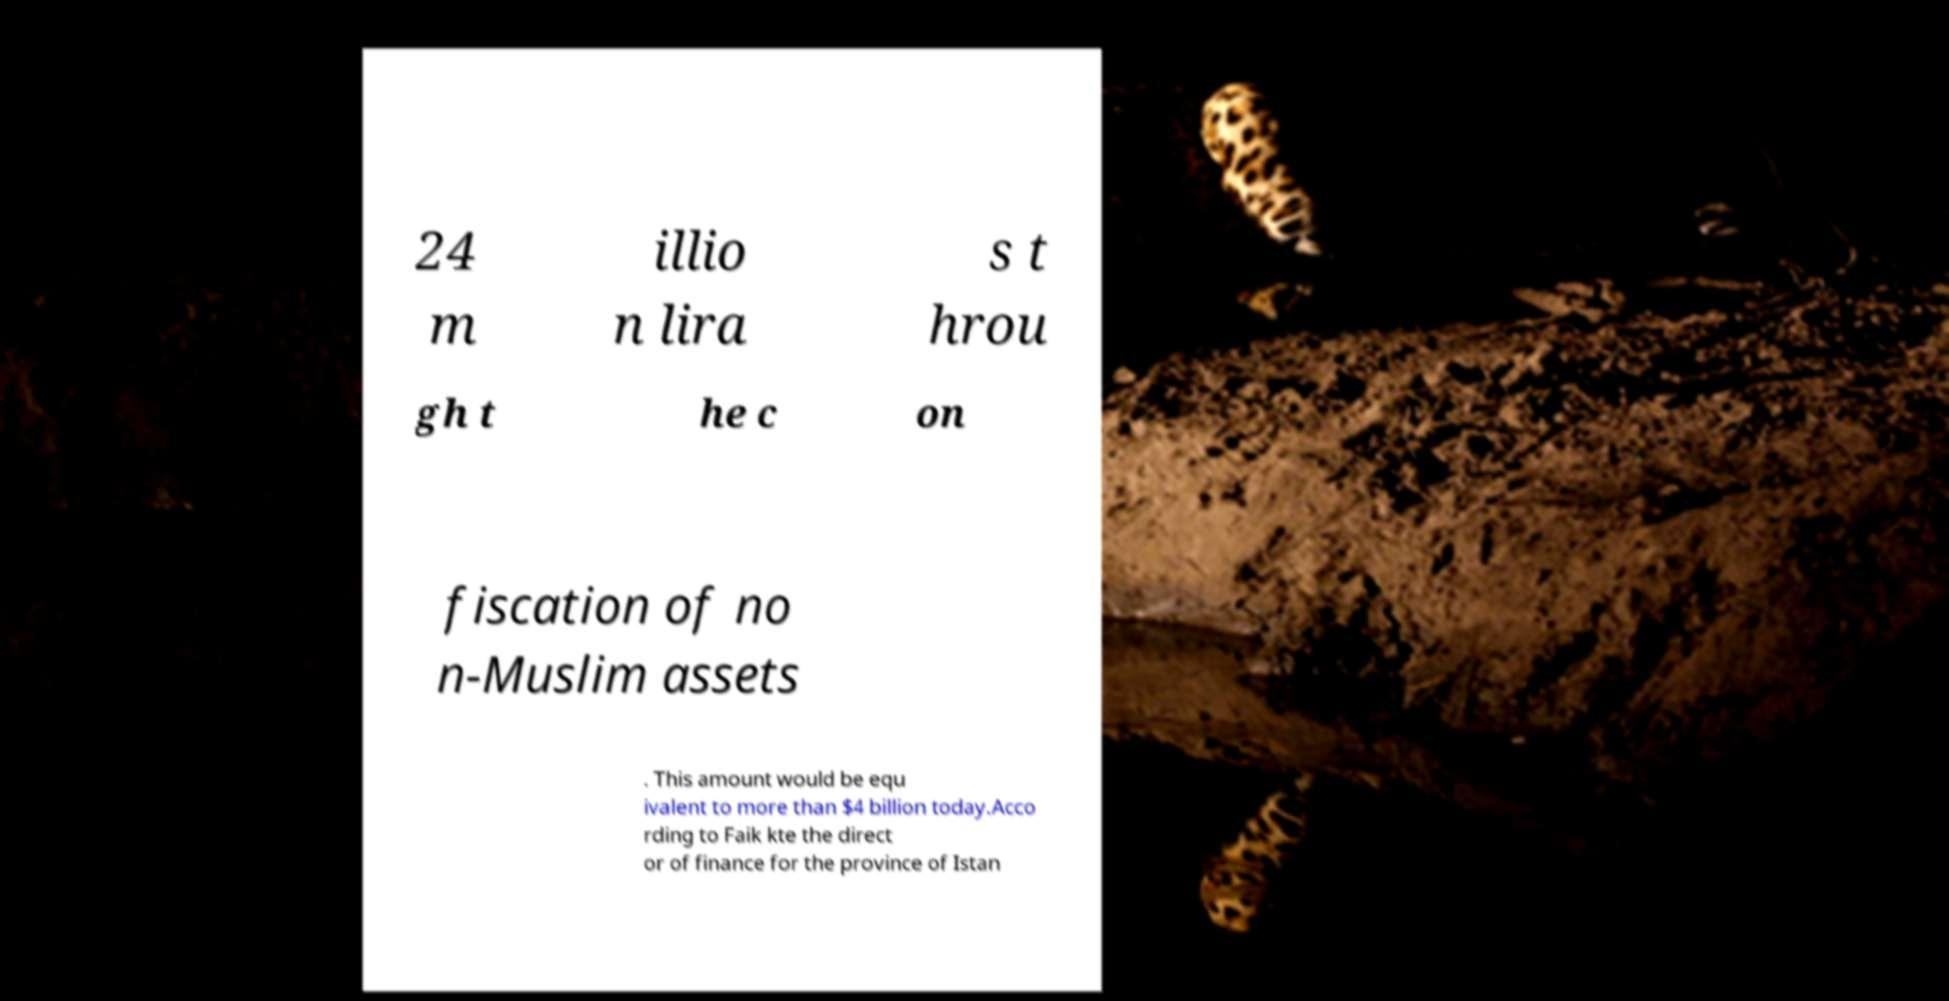Can you accurately transcribe the text from the provided image for me? 24 m illio n lira s t hrou gh t he c on fiscation of no n-Muslim assets . This amount would be equ ivalent to more than $4 billion today.Acco rding to Faik kte the direct or of finance for the province of Istan 